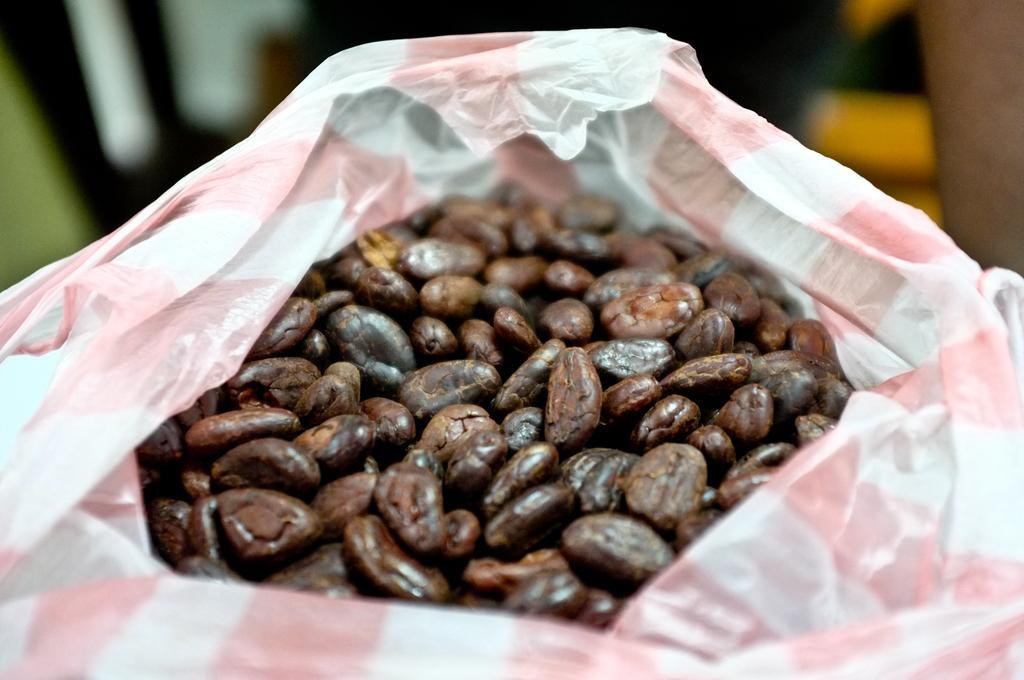What is the main subject of the image? The main subject of the image is seeds. How are the seeds contained in the image? The seeds are in a polythene bag. Where are the seeds located in the image? The seeds are in the center of the image. Can you describe the background of the image? The background of the image is blurry. Can you tell me how many beans are in the frame in the image? There are no beans present in the image, and the term "frame" is not relevant to the image. 